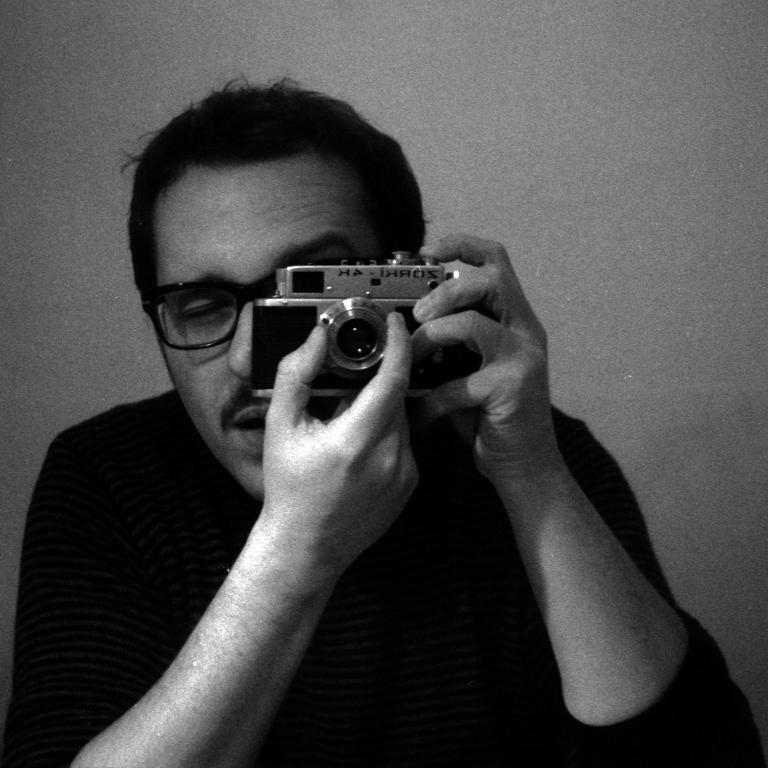What is the color scheme of the image? The image is black and white. Who is present in the image? There is a man in the image. What is the man wearing? The man is wearing a t-shirt. What is the man holding in the image? The man is holding a camera. What is the man doing with the camera? The man is adjusting something on the camera. What can be seen in the background of the image? There is a wall in the background of the image. Can you see any cactus plants in the image? There are no cactus plants present in the image. How many cherries are on the man's t-shirt in the image? The man's t-shirt does not have any cherries on it; it is not mentioned in the provided facts. 